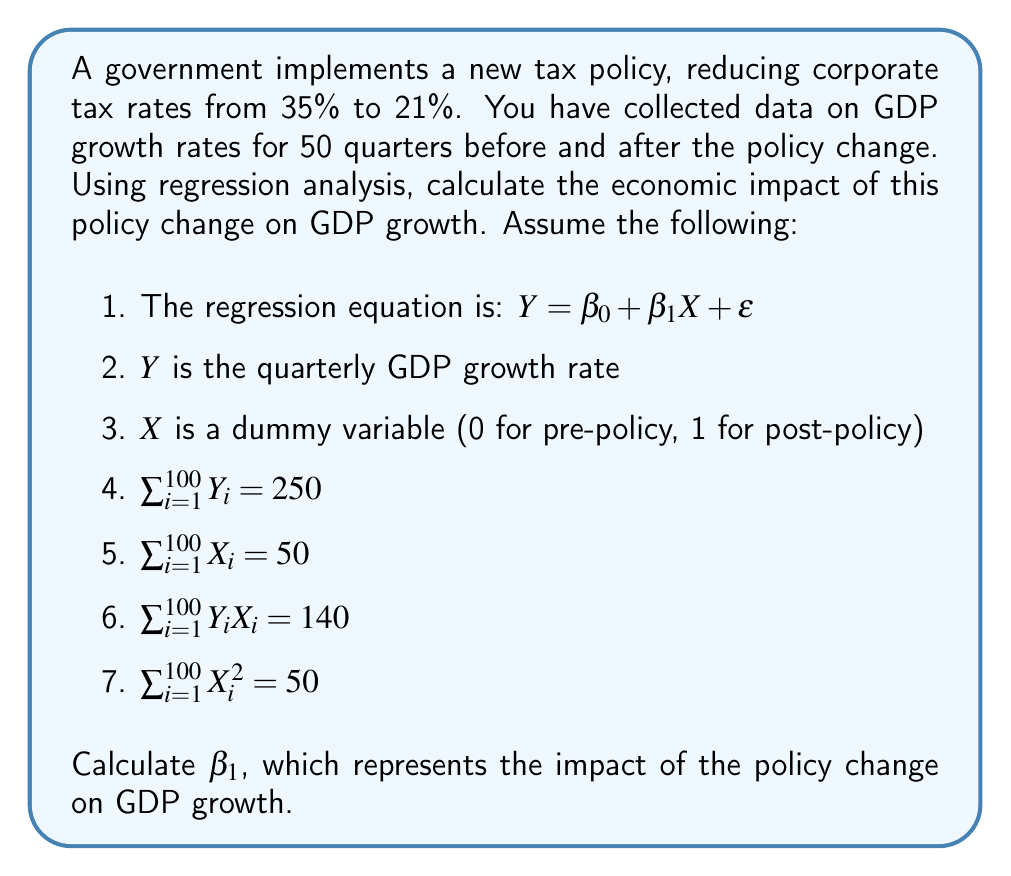Help me with this question. To calculate $\beta_1$ using regression analysis, we'll use the formula for the slope in simple linear regression:

$$\beta_1 = \frac{n\sum XY - \sum X \sum Y}{n\sum X^2 - (\sum X)^2}$$

Where:
- $n$ is the number of observations (100 quarters)
- $\sum XY$ is the sum of the product of X and Y
- $\sum X$ is the sum of X values
- $\sum Y$ is the sum of Y values
- $\sum X^2$ is the sum of squared X values

Let's substitute the given values:

1. $n = 100$
2. $\sum XY = 140$
3. $\sum X = 50$
4. $\sum Y = 250$
5. $\sum X^2 = 50$

Now, let's calculate $\beta_1$:

$$\beta_1 = \frac{100(140) - 50(250)}{100(50) - 50^2}$$

$$\beta_1 = \frac{14000 - 12500}{5000 - 2500}$$

$$\beta_1 = \frac{1500}{2500}$$

$$\beta_1 = 0.6$$

The value of $\beta_1$ is 0.6, which represents the average increase in quarterly GDP growth rate after the implementation of the new tax policy.
Answer: $\beta_1 = 0.6$ 